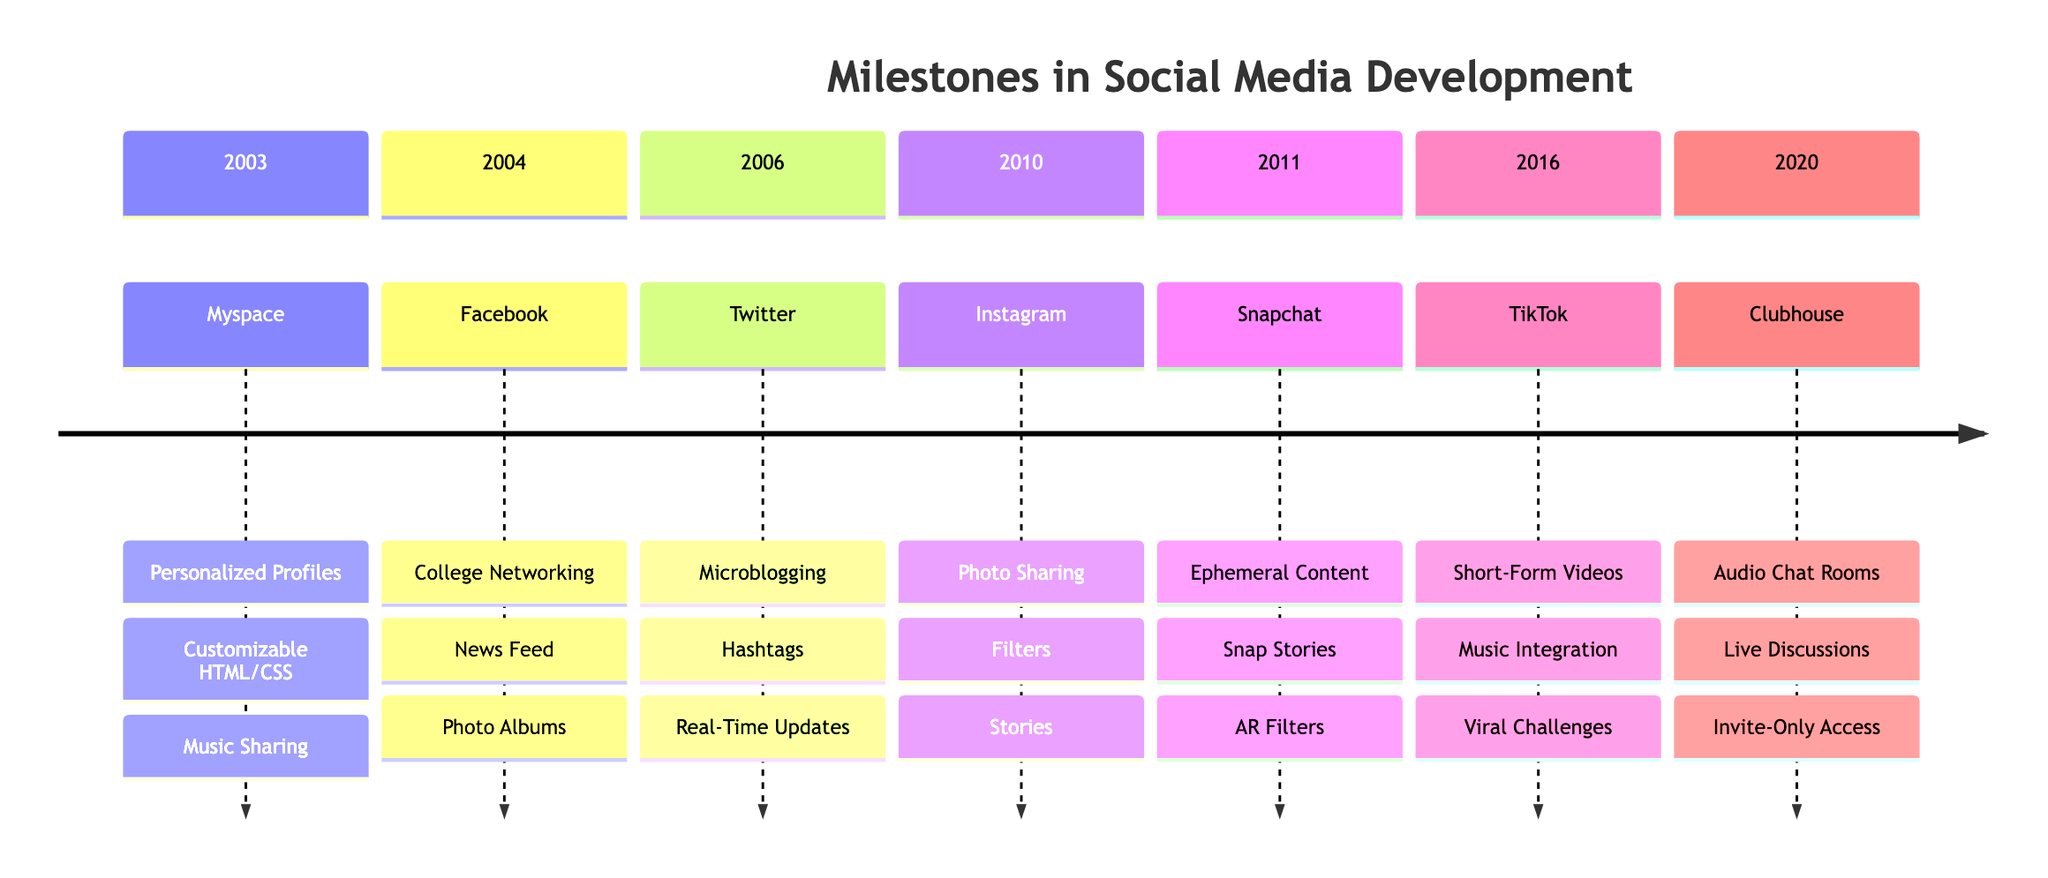What platform was launched in 2003? The diagram indicates that Myspace was the platform launched in 2003.
Answer: Myspace How many key features does Instagram have listed? The diagram shows that there are three key features associated with Instagram, which are photo sharing, filters, and stories.
Answer: 3 What year was Twitter launched? According to the timeline, Twitter was launched in 2006.
Answer: 2006 Which platform features audio chat rooms? The diagram indicates that Clubhouse is the platform featuring audio chat rooms among its key features.
Answer: Clubhouse Which platform popularized ephemeral content in 2011? The timeline shows that Snapchat was the platform that popularized ephemeral content in the year 2011.
Answer: Snapchat What feature is common to both TikTok and Instagram? Both TikTok and Instagram share the feature of enabling users to create and share short-form content, categorized as short-form videos on TikTok and stories or photo sharing on Instagram.
Answer: Video and Image Sharing What major trend did Facebook introduce with the News Feed? The diagram suggests that the introduction of the News Feed by Facebook was part of the trend towards real-life social connections and expansive user engagement.
Answer: Real-Life Social Connection In which year did TikTok become prominent for viral challenges? The timeline reveals that TikTok became prominent for viral challenges in 2016.
Answer: 2016 What is a notable trend associated with Snapchat? The diagram lists temporary content popularity as a notable trend associated with Snapchat's key features.
Answer: Temporary Content Popularity 